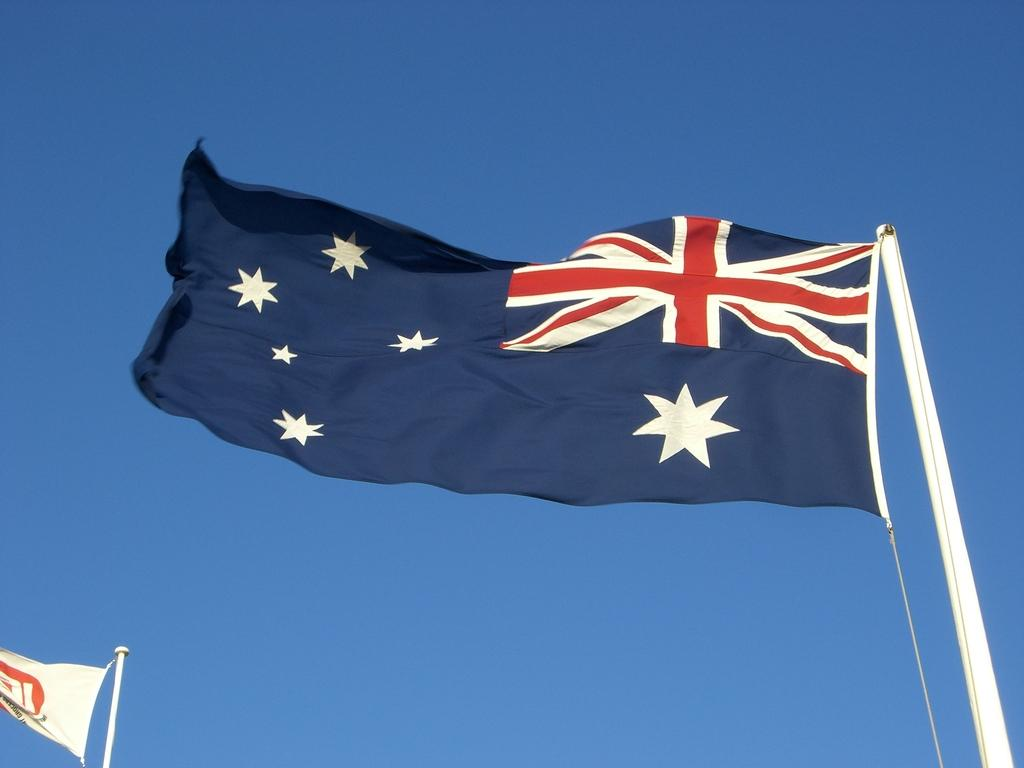What can be seen on the poles in the image? There are two poles with flags in the image. What is depicted on the flag on the right side? The flag on the right side has star images on it. What is visible in the background of the image? The background of the image includes the sky. How many toes can be seen on the representative in the image? There is no representative present in the image, so it is not possible to determine the number of toes visible. 